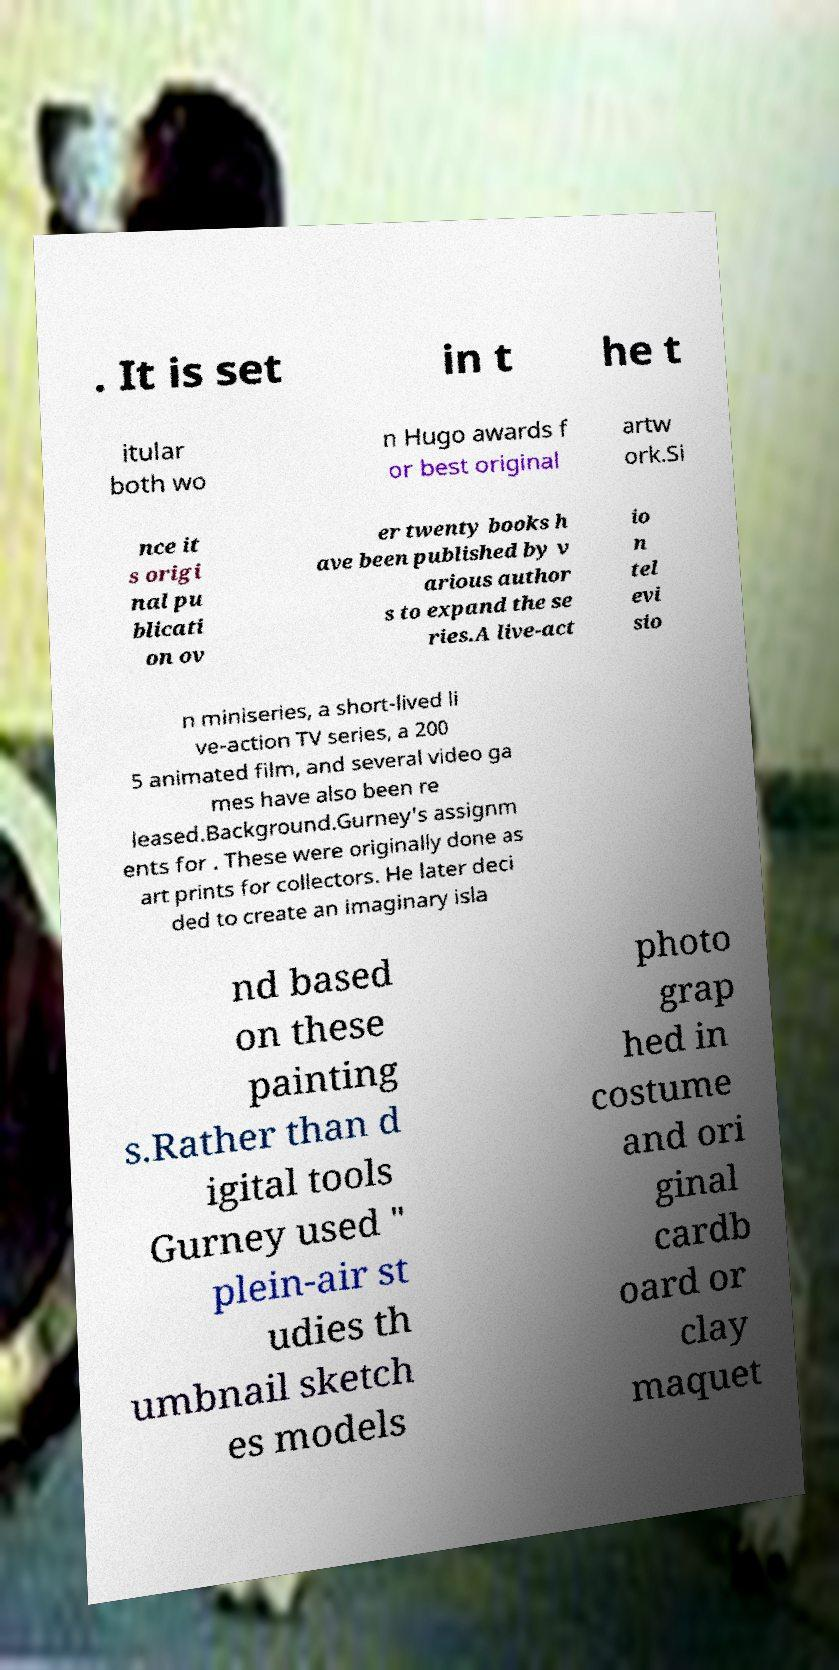Please read and relay the text visible in this image. What does it say? . It is set in t he t itular both wo n Hugo awards f or best original artw ork.Si nce it s origi nal pu blicati on ov er twenty books h ave been published by v arious author s to expand the se ries.A live-act io n tel evi sio n miniseries, a short-lived li ve-action TV series, a 200 5 animated film, and several video ga mes have also been re leased.Background.Gurney's assignm ents for . These were originally done as art prints for collectors. He later deci ded to create an imaginary isla nd based on these painting s.Rather than d igital tools Gurney used " plein-air st udies th umbnail sketch es models photo grap hed in costume and ori ginal cardb oard or clay maquet 